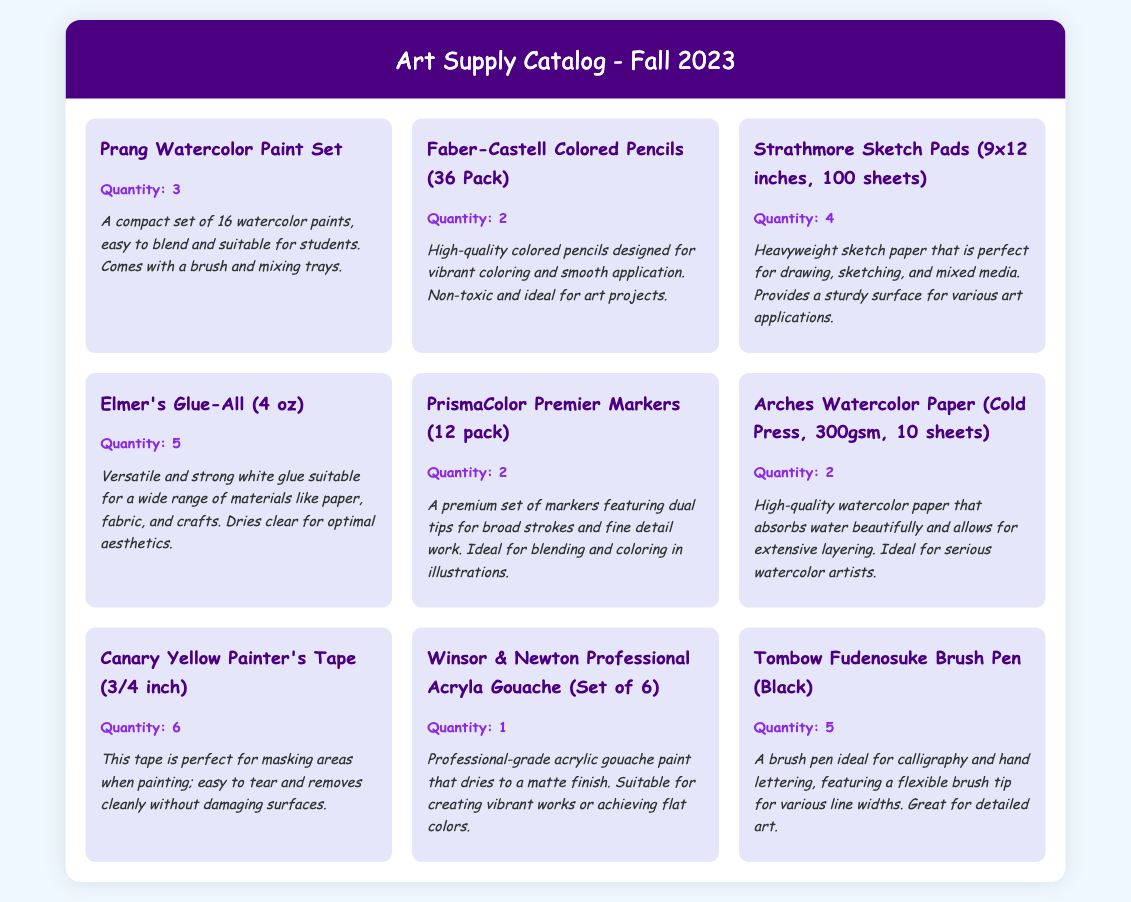What is the first item listed in the catalog? The first item in the grid is the "Prang Watercolor Paint Set."
Answer: Prang Watercolor Paint Set How many Strathmore Sketch Pads are available? The quantity of Strathmore Sketch Pads listed is 4.
Answer: 4 What color is the Tombow Fudenosuke Brush Pen? The Tombow Fudenosuke Brush Pen listed is black.
Answer: Black How many items are there that have a quantity of 2? There are 3 items listed with a quantity of 2: Faber-Castell Colored Pencils, PrismaColor Premier Markers, and Arches Watercolor Paper.
Answer: 3 What is the description of the Elmer's Glue-All? The description states it's a versatile and strong white glue suitable for a wide range of materials.
Answer: Versatile and strong white glue suitable for a wide range of materials Which item has the highest quantity available? The item with the highest quantity available is the Canary Yellow Painter's Tape with 6.
Answer: 6 What type of paint is Winsor & Newton Professional Acryla Gouache? It is professional-grade acrylic gouache paint.
Answer: Acrylic gouache paint How many sheets are in the Arches Watercolor Paper pack? The Arches Watercolor Paper pack contains 10 sheets.
Answer: 10 sheets What is the main use of the Faber-Castell Colored Pencils? The primary use is for vibrant coloring and smooth application.
Answer: Vibrant coloring and smooth application 